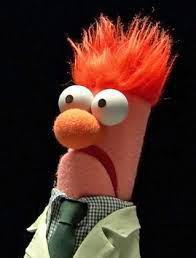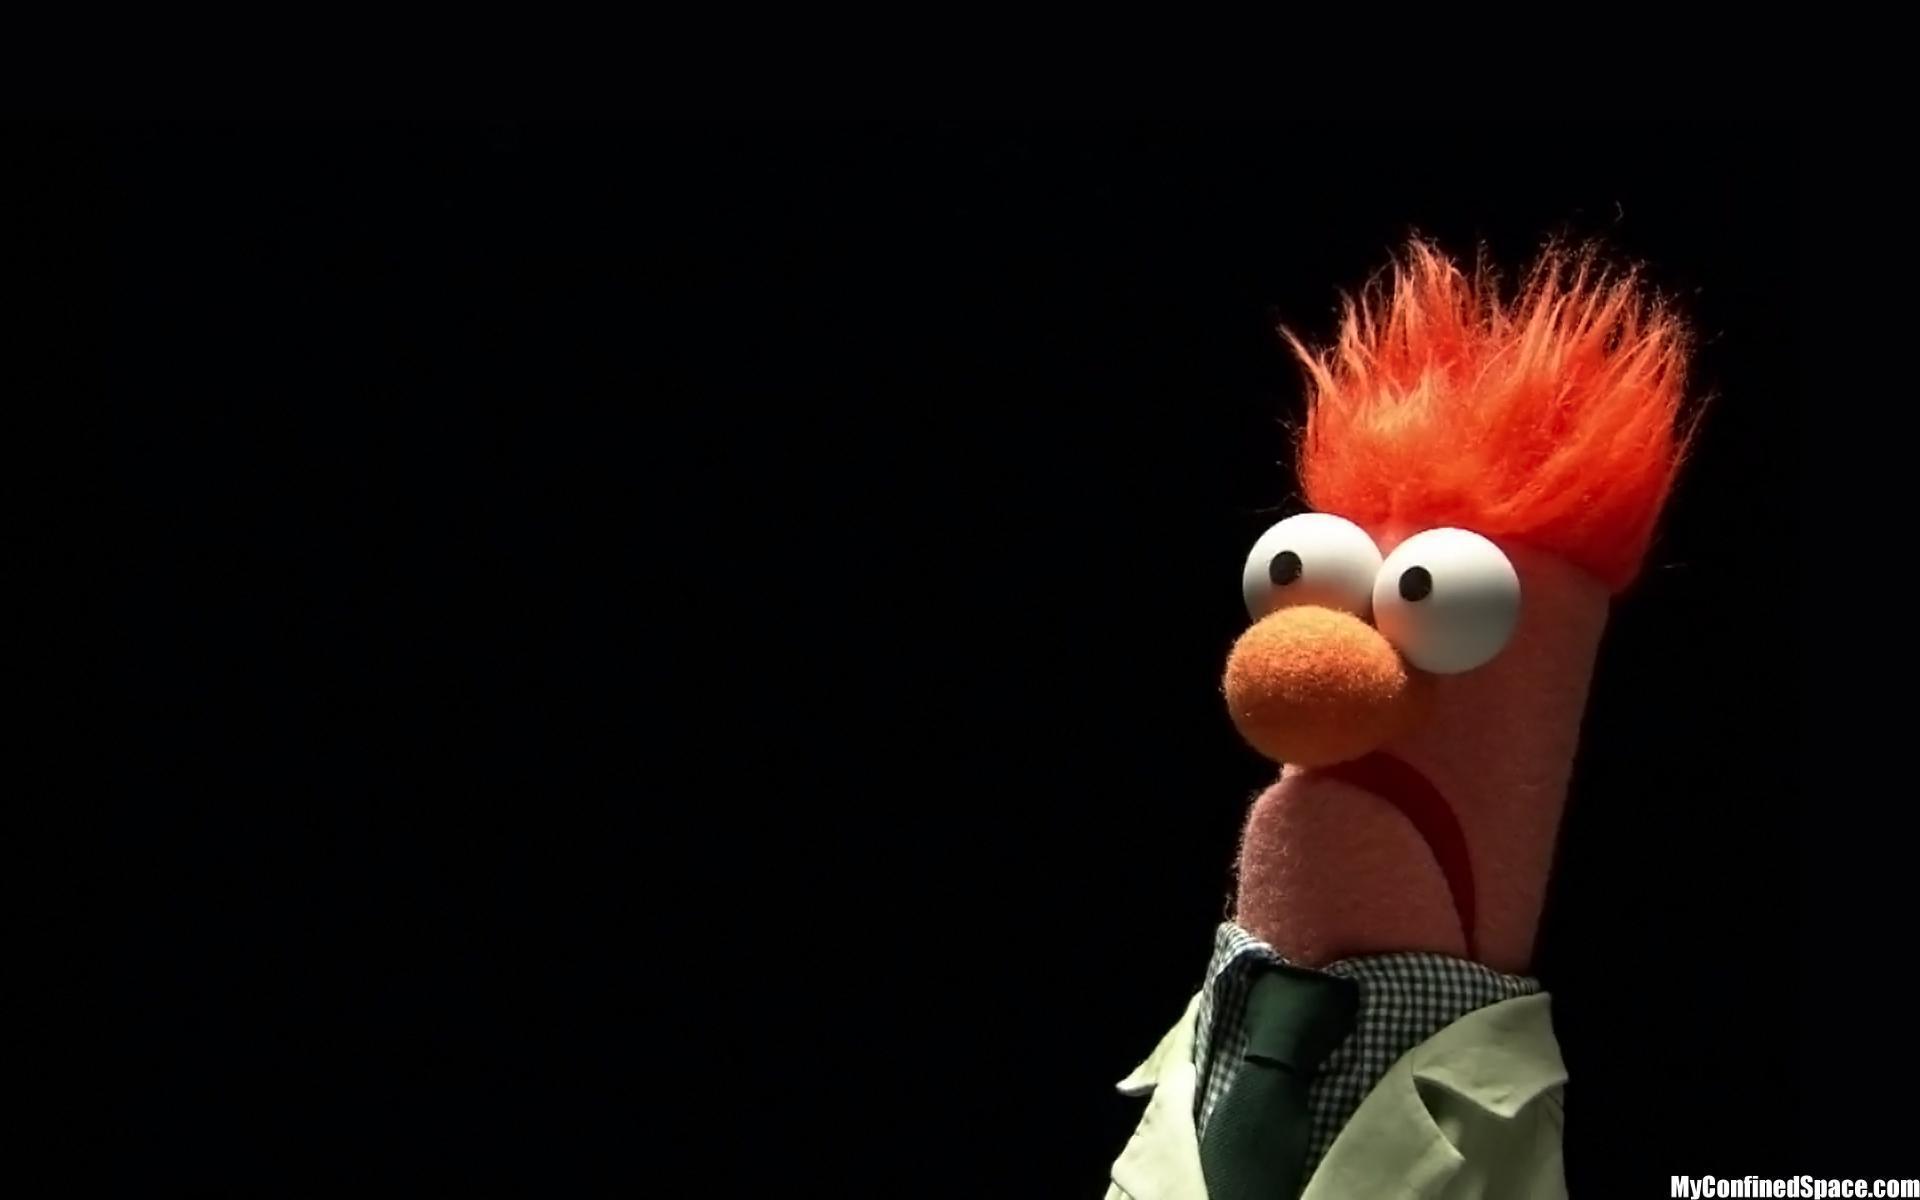The first image is the image on the left, the second image is the image on the right. Assess this claim about the two images: "The puppet is facing to the right in the image on the right.". Correct or not? Answer yes or no. No. 